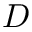Convert formula to latex. <formula><loc_0><loc_0><loc_500><loc_500>D</formula> 